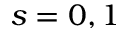<formula> <loc_0><loc_0><loc_500><loc_500>s = 0 , 1</formula> 